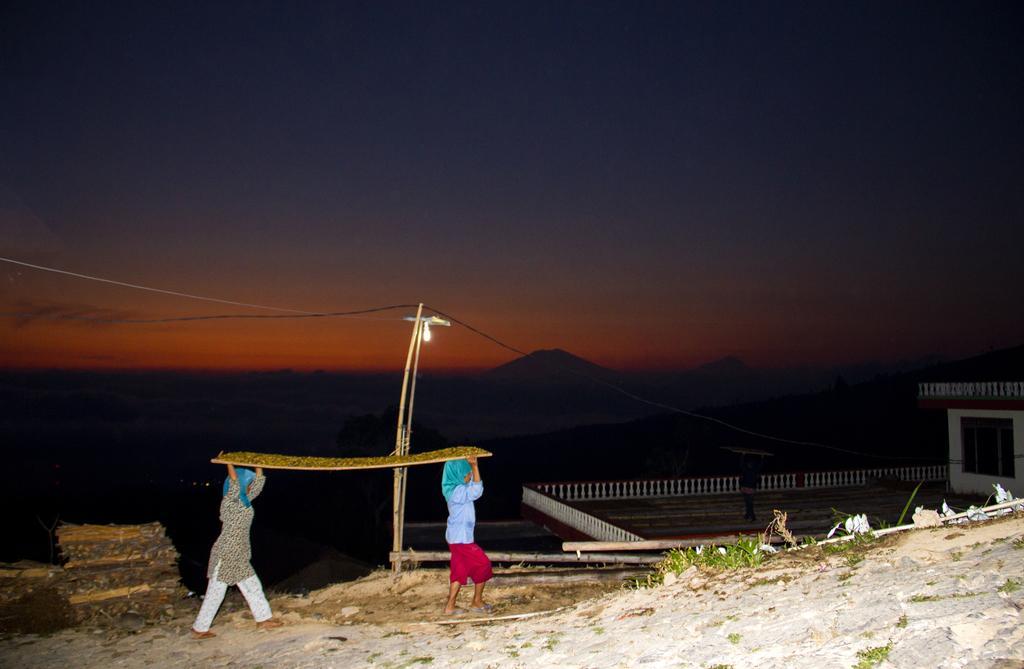Could you give a brief overview of what you see in this image? In the there are two persons walking and holding an object in their hands. Behind them there are wooden logs. And also there is a pole with a bulb. And also there is a building with railings, walls and windows. In the background there are hills. At the top of the image there is sky.  